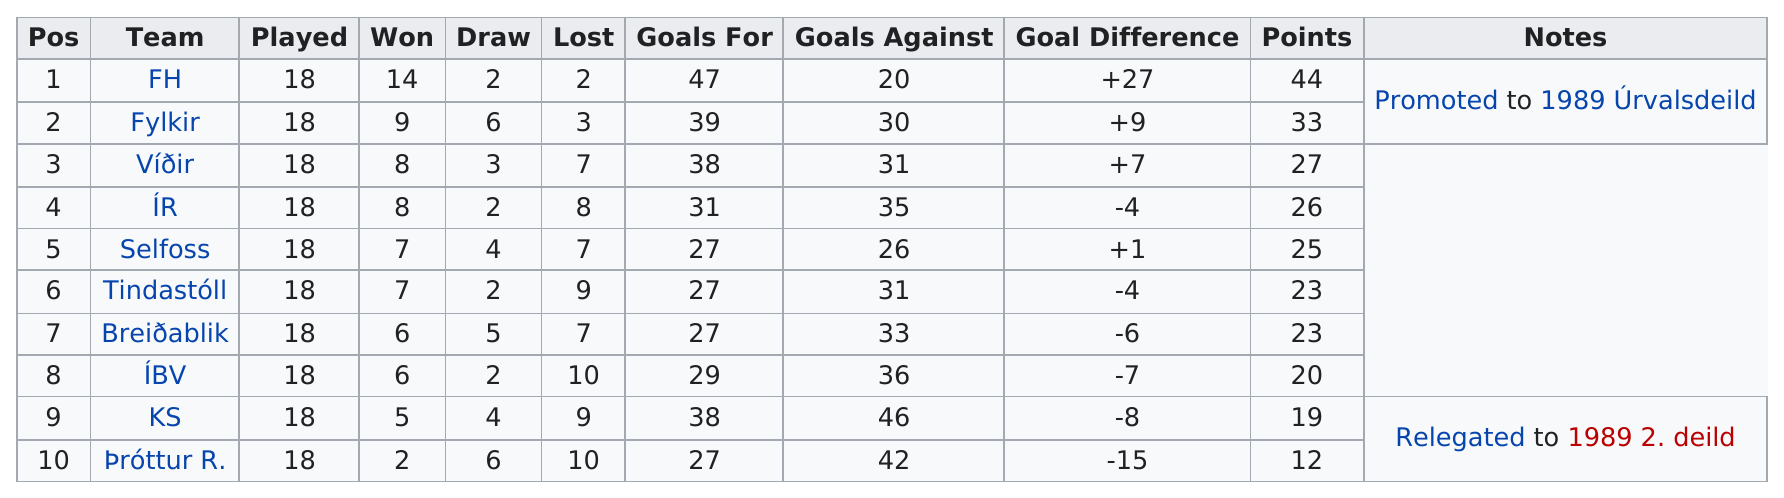Draw attention to some important aspects in this diagram. KS had the most goals scored against themselves for the year. At what point do the goals against outnumber the goals for? What team(s) has the highest win/loss ratio? According to the information provided, the number of goals scored by KS was 38. The team with the second highest number of points after Team FH was Fylkir. 